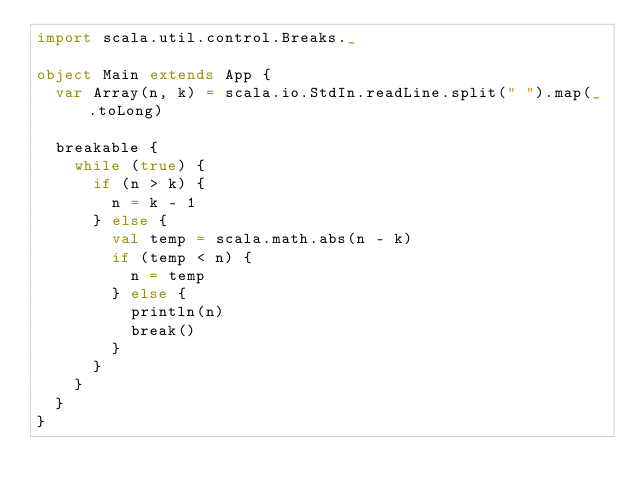Convert code to text. <code><loc_0><loc_0><loc_500><loc_500><_Scala_>import scala.util.control.Breaks._

object Main extends App {
  var Array(n, k) = scala.io.StdIn.readLine.split(" ").map(_.toLong)

  breakable {
    while (true) {
      if (n > k) {
        n = k - 1
      } else {
        val temp = scala.math.abs(n - k)
        if (temp < n) {
          n = temp
        } else {
          println(n)
          break()
        }
      }
    }
  }
}
</code> 